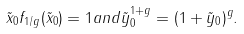Convert formula to latex. <formula><loc_0><loc_0><loc_500><loc_500>\tilde { x } _ { 0 } f _ { 1 / g } ( \tilde { x } _ { 0 } ) = 1 a n d \tilde { y } _ { 0 } ^ { 1 + g } = ( 1 + \tilde { y } _ { 0 } ) ^ { g } .</formula> 